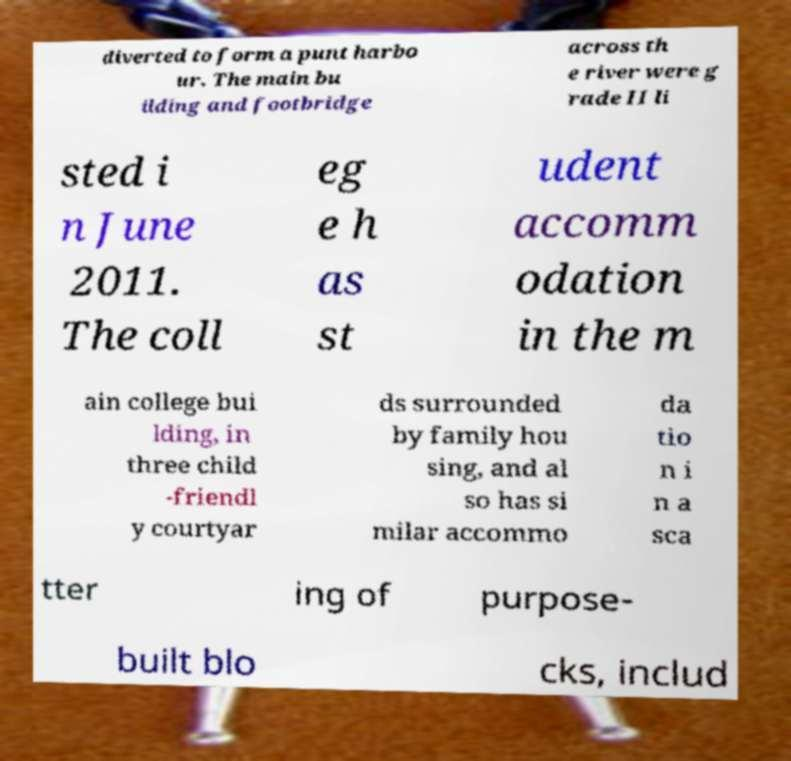Could you extract and type out the text from this image? diverted to form a punt harbo ur. The main bu ilding and footbridge across th e river were g rade II li sted i n June 2011. The coll eg e h as st udent accomm odation in the m ain college bui lding, in three child -friendl y courtyar ds surrounded by family hou sing, and al so has si milar accommo da tio n i n a sca tter ing of purpose- built blo cks, includ 